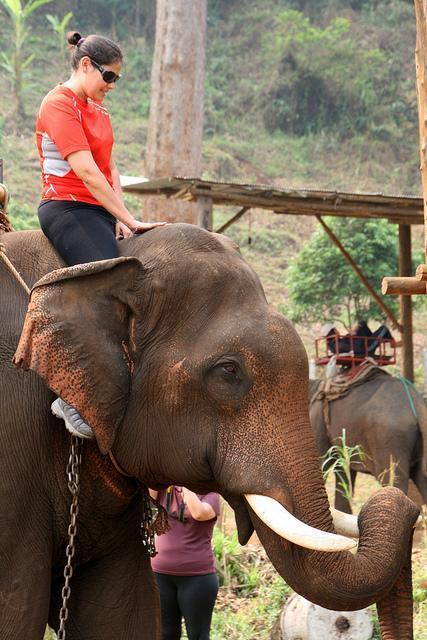How many elephants are there?
Give a very brief answer. 2. How many people are in the photo?
Give a very brief answer. 2. 